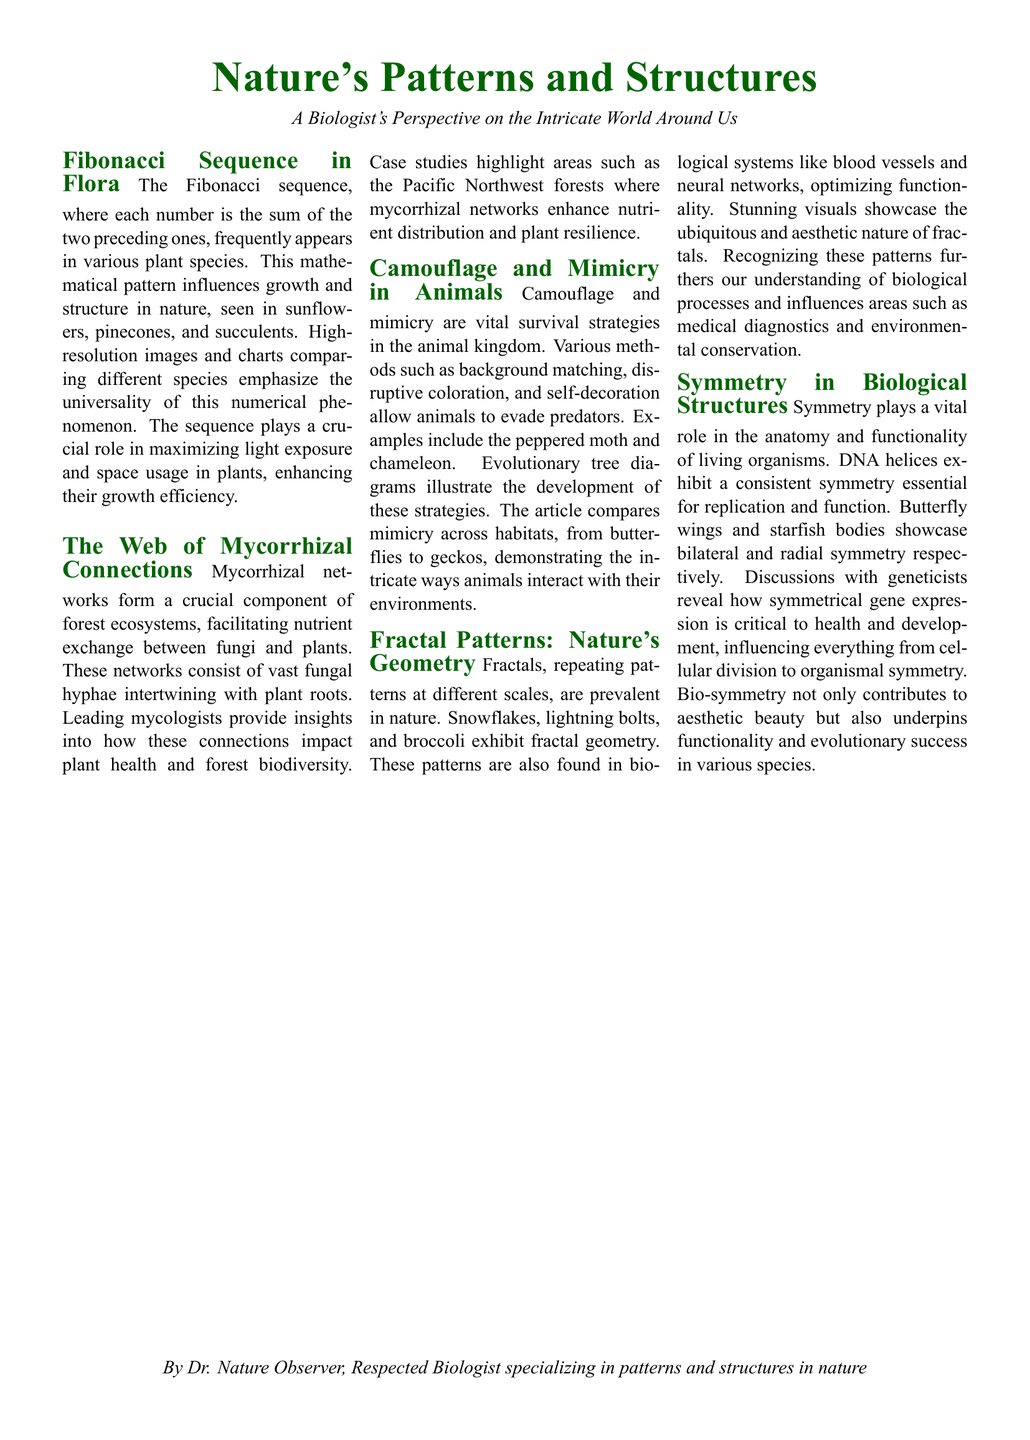What is the title of the first article? The title is explicitly mentioned at the start of the article section in the document.
Answer: Fibonacci Sequence in Flora How does the Fibonacci sequence influence plant growth? The document states the Fibonacci sequence enhances growth efficiency by maximizing light exposure and space usage in plants.
Answer: Maximizing light exposure What is the main function of mycorrhizal networks? The article describes mycorrhizal networks as facilitating nutrient exchange between fungi and plants.
Answer: Nutrient exchange Which animal is mentioned as an example of mimicry? The document provides specific examples within the section discussing camouflage and mimicry in animals.
Answer: Chameleon What natural phenomenon exhibits fractal patterns? The article mentions several examples of natural phenomena that demonstrate fractal geometry.
Answer: Snowflakes What is the role of symmetry in biological structures? The article discusses symmetry as essential for function and aesthetics in living organisms.
Answer: Critical for function Who contributed insights into mycorrhizal networks? The document mentions leading mycologists providing insights within the section on mycorrhizal connections.
Answer: Leading mycologists What is highlighted as a feature of fractals in the article? The article notes that fractals are repeating patterns present at different scales in nature.
Answer: Repeating patterns at different scales 